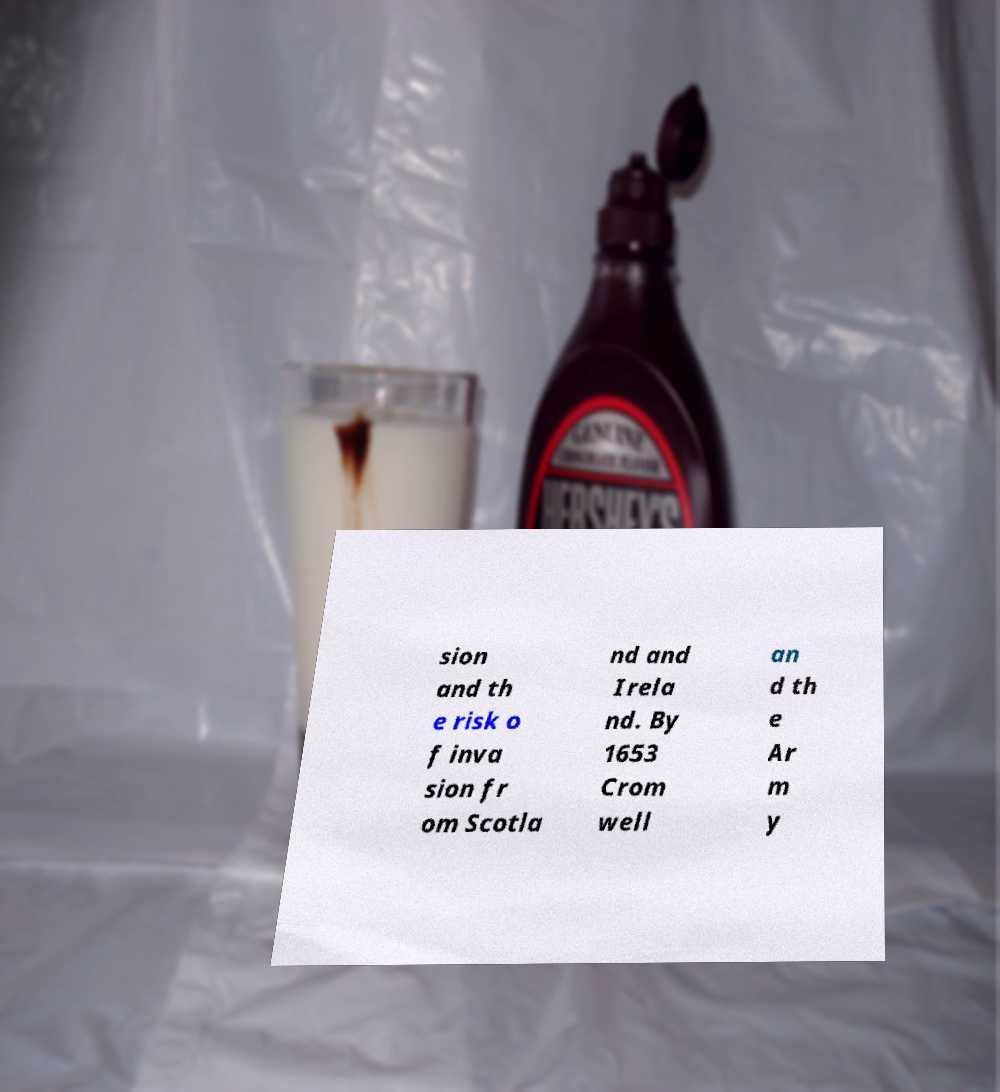There's text embedded in this image that I need extracted. Can you transcribe it verbatim? sion and th e risk o f inva sion fr om Scotla nd and Irela nd. By 1653 Crom well an d th e Ar m y 